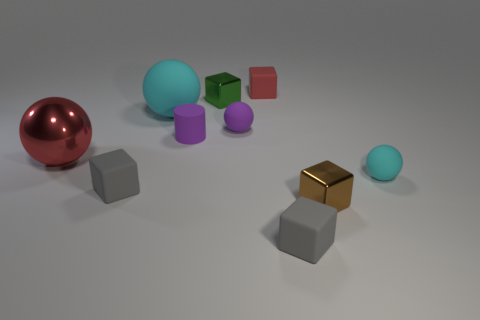Subtract all red cubes. How many cubes are left? 4 Subtract all green blocks. How many blocks are left? 4 Subtract all yellow blocks. Subtract all red cylinders. How many blocks are left? 5 Subtract all purple cylinders. How many purple cubes are left? 0 Subtract all red metallic spheres. Subtract all tiny rubber cylinders. How many objects are left? 8 Add 2 tiny purple things. How many tiny purple things are left? 4 Add 2 large cyan objects. How many large cyan objects exist? 3 Subtract 0 yellow balls. How many objects are left? 10 Subtract all balls. How many objects are left? 6 Subtract 4 balls. How many balls are left? 0 